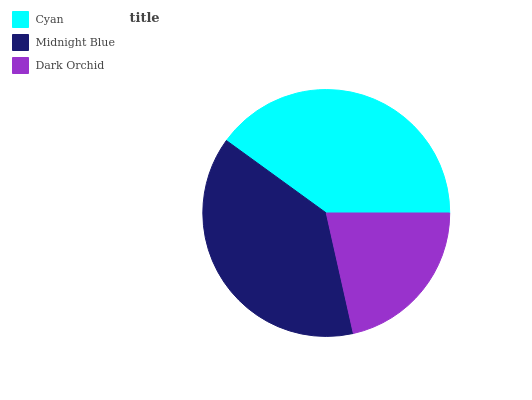Is Dark Orchid the minimum?
Answer yes or no. Yes. Is Cyan the maximum?
Answer yes or no. Yes. Is Midnight Blue the minimum?
Answer yes or no. No. Is Midnight Blue the maximum?
Answer yes or no. No. Is Cyan greater than Midnight Blue?
Answer yes or no. Yes. Is Midnight Blue less than Cyan?
Answer yes or no. Yes. Is Midnight Blue greater than Cyan?
Answer yes or no. No. Is Cyan less than Midnight Blue?
Answer yes or no. No. Is Midnight Blue the high median?
Answer yes or no. Yes. Is Midnight Blue the low median?
Answer yes or no. Yes. Is Cyan the high median?
Answer yes or no. No. Is Cyan the low median?
Answer yes or no. No. 